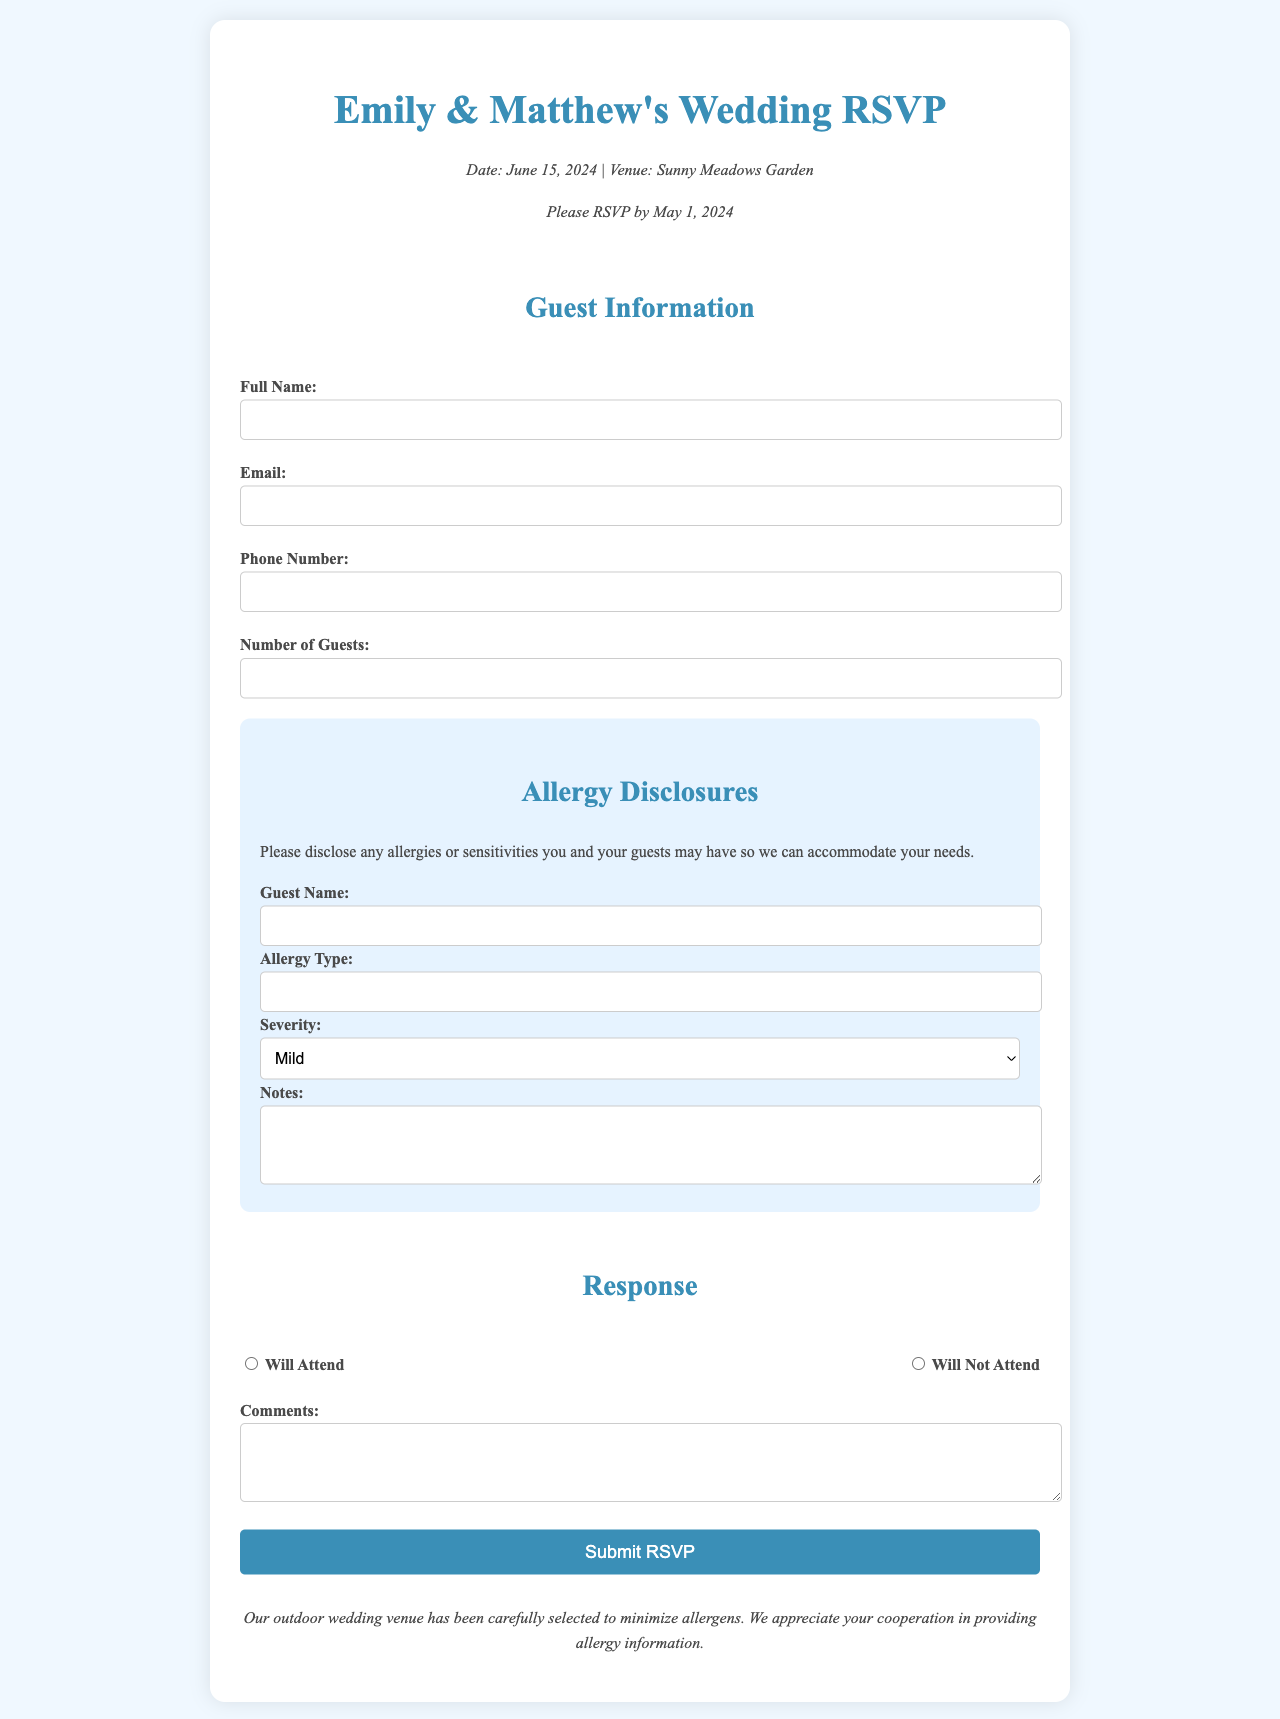What is the date of the wedding? The date of the wedding is clearly stated in the event details section of the document.
Answer: June 15, 2024 What is the location of the wedding? The venue for the wedding is mentioned in the event details section of the document.
Answer: Sunny Meadows Garden What is the RSVP deadline? The document specifies the date by which guests should respond to the RSVP.
Answer: May 1, 2024 What type of allergies should guests disclose? The allergy disclosures section asks for any allergies or sensitivities, which includes various types.
Answer: Any allergies or sensitivities What are the severity options for allergies? Three severity levels for allergies are presented in a dropdown selection within the allergy section.
Answer: Mild, Moderate, Severe How many guests can be entered in the guest count? The input field for guest count requires a minimum value, which indicates how many guests can attend.
Answer: Minimum 1 guest What is the purpose of the allergy disclosures section? This section is included to help accommodate guest needs regarding their allergies.
Answer: To accommodate guest needs What is the text color in the document? The document specifies the color of the text that is used throughout the content.
Answer: #4a4a4a What kind of button is used to submit the RSVP? The document describes the appearance and purpose of a specific button in the form.
Answer: Submit RSVP button 